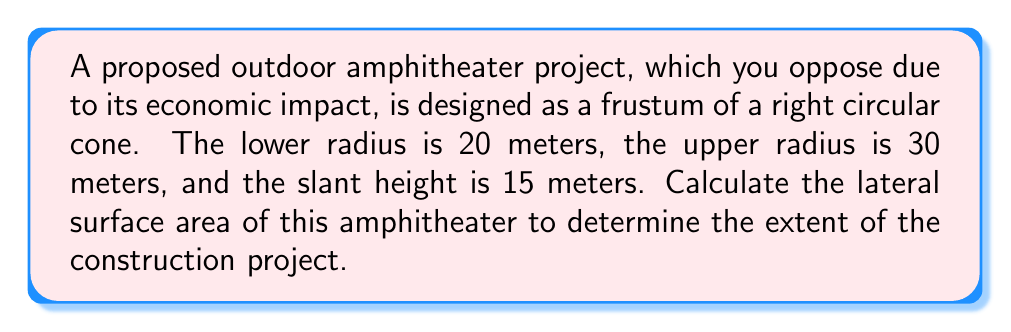Give your solution to this math problem. To calculate the lateral surface area of a frustum, we use the formula:

$$A = \pi(r_1 + r_2)s$$

Where:
$r_1$ = radius of the lower base
$r_2$ = radius of the upper base
$s$ = slant height

Given:
$r_1 = 20$ meters
$r_2 = 30$ meters
$s = 15$ meters

Step 1: Substitute the values into the formula:
$$A = \pi(20 + 30) \times 15$$

Step 2: Simplify inside the parentheses:
$$A = \pi(50) \times 15$$

Step 3: Multiply:
$$A = 50\pi \times 15 = 750\pi$$

Step 4: Calculate the final result:
$$A = 750\pi \approx 2356.19 \text{ m}^2$$

[asy]
import geometry;

size(200);
pair A = (0,0), B = (4,0), C = (6,3), D = (1.5,3);
draw(A--B--C--D--cycle);
draw(B--D,dashed);
label("20m",A--B,S);
label("30m",C--D,N);
label("15m",B--D,E);
[/asy]
Answer: $2356.19 \text{ m}^2$ 